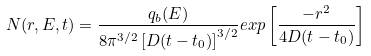<formula> <loc_0><loc_0><loc_500><loc_500>N ( r , E , t ) = \frac { q _ { b } ( E ) } { 8 \pi ^ { 3 / 2 } \left [ D ( t - t _ { 0 } ) \right ] ^ { 3 / 2 } } e x p \left [ \frac { - r ^ { 2 } } { 4 D ( t - t _ { 0 } ) } \right ]</formula> 